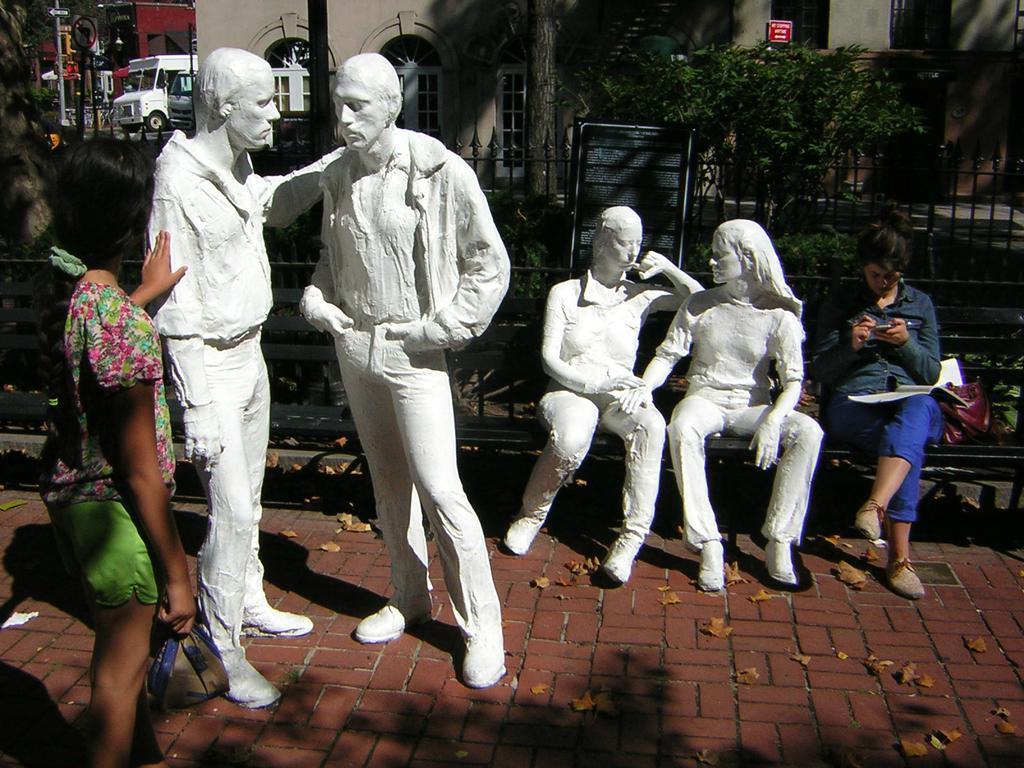Please provide a concise description of this image. Here I can see four statues of persons. On the left side a woman is holding statue and standing. On the right side another woman is sitting on the bench, holding a mobile in the hands and looking at the mobile. Beside her I can see a bag. In the background there are some plants, buildings and also I can see vehicles on the road. 